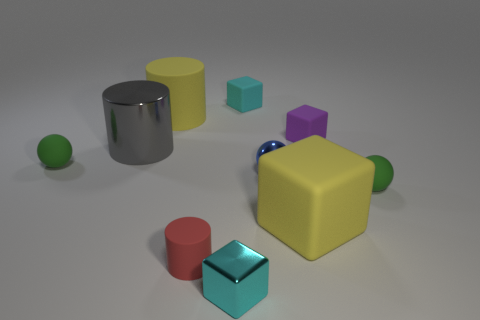Subtract all blue metallic spheres. How many spheres are left? 2 Subtract all balls. How many objects are left? 7 Subtract 1 balls. How many balls are left? 2 Subtract all brown cylinders. How many gray balls are left? 0 Subtract all large gray objects. Subtract all large purple blocks. How many objects are left? 9 Add 1 yellow rubber cylinders. How many yellow rubber cylinders are left? 2 Add 8 large blue objects. How many large blue objects exist? 8 Subtract all purple blocks. How many blocks are left? 3 Subtract 0 cyan cylinders. How many objects are left? 10 Subtract all blue cylinders. Subtract all gray blocks. How many cylinders are left? 3 